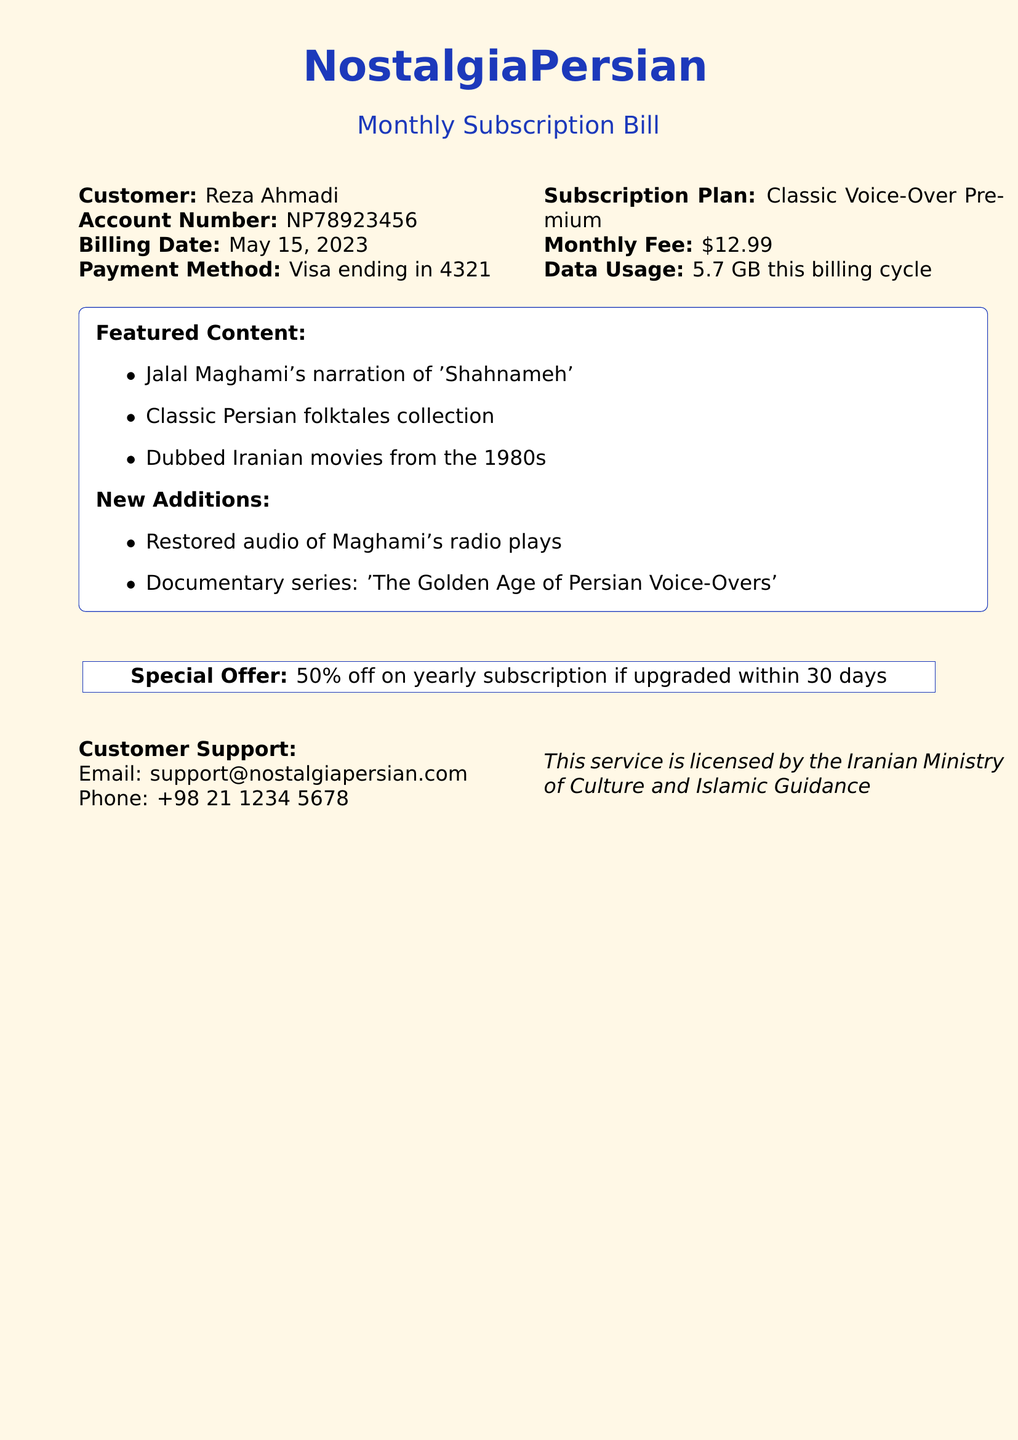what is the customer's name? The document specifies the customer's name as Reza Ahmadi.
Answer: Reza Ahmadi what is the account number? The account number provided in the document is NP78923456.
Answer: NP78923456 what is the monthly fee for the subscription? The document states the monthly fee as $12.99.
Answer: $12.99 what is featured content in the streaming service? The featured content includes Jalal Maghami's narration of 'Shahnameh' and more.
Answer: Jalal Maghami's narration of 'Shahnameh' when was the billing date? The billing date listed in the document is May 15, 2023.
Answer: May 15, 2023 what is the data usage in this billing cycle? According to the document, the data usage is 5.7 GB.
Answer: 5.7 GB what is the name of the special offer? The document refers to the special offer as 50% off on yearly subscription.
Answer: 50% off on yearly subscription what payment method was used? The payment method mentioned in the document is Visa ending in 4321.
Answer: Visa ending in 4321 what are the new additions in the content library? The new additions include restored audio of Maghami's radio plays and a documentary series.
Answer: Restored audio of Maghami's radio plays 